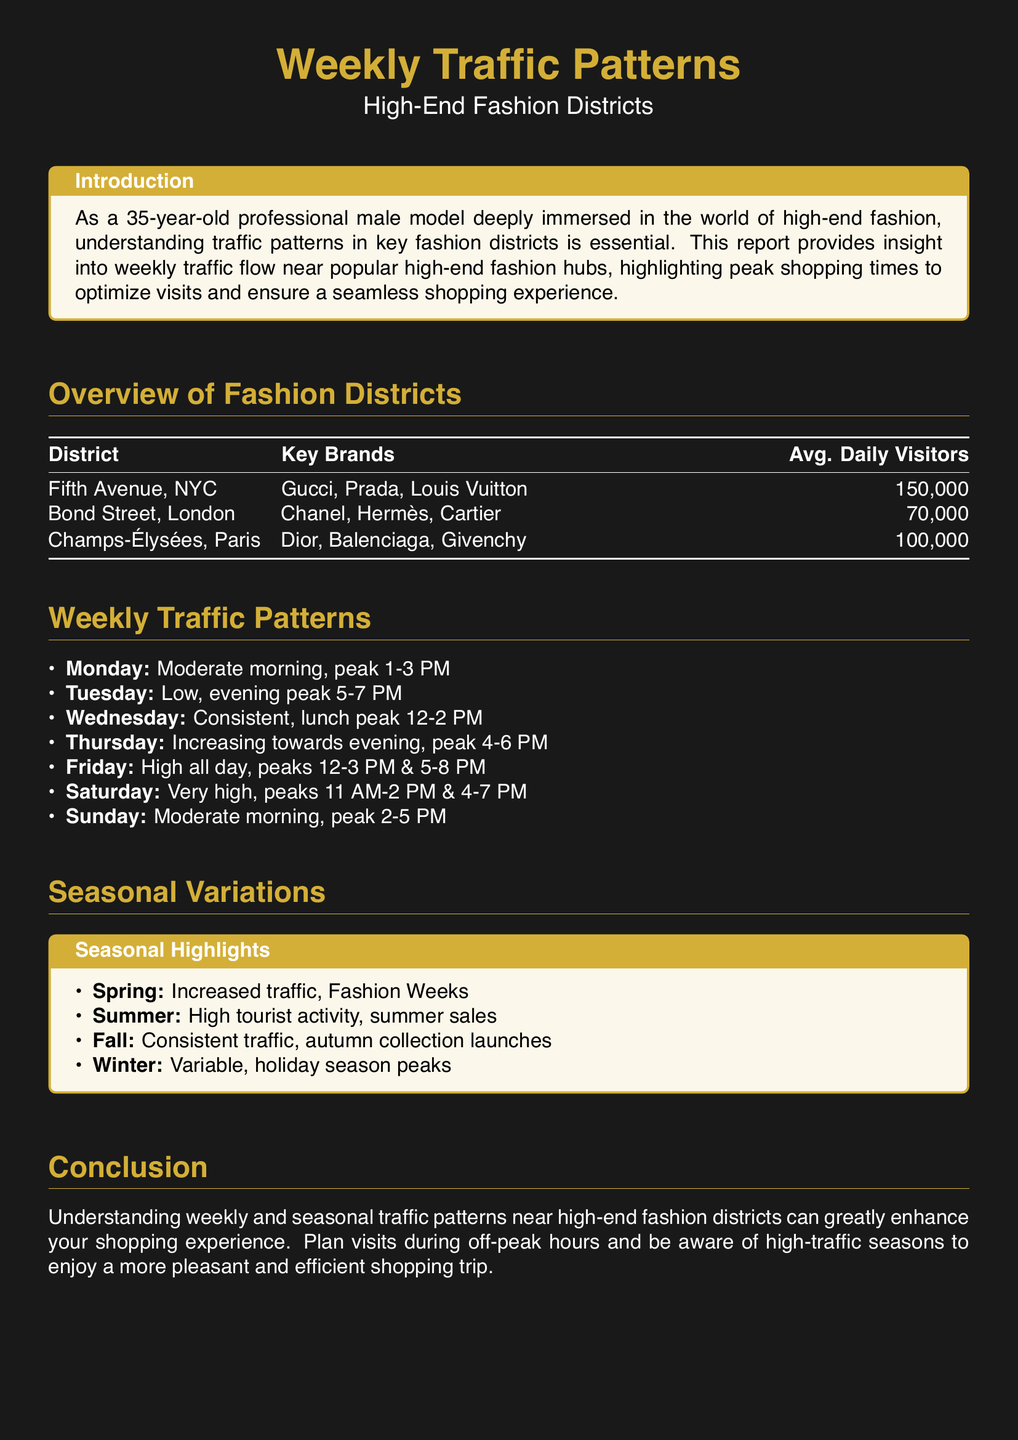What is the average daily visitors for Fifth Avenue? The average daily visitors for Fifth Avenue is explicitly mentioned in the overview table.
Answer: 150,000 What is the peak shopping time on Fridays? The report outlines peak shopping times during the week, specifying timings for each day.
Answer: 12-3 PM & 5-8 PM Which district has the lowest average daily visitors? By comparing the average daily visitors in the overview table, we can find the district with the lowest count.
Answer: Bond Street, London How does traffic vary in spring? This information can be gathered from the seasonal highlights section regarding spring traffic patterns.
Answer: Increased traffic, Fashion Weeks What is the average daily visitor count for Champs-Élysées? The overview table lists the average daily visitors for this district.
Answer: 100,000 What time on Saturdays sees the highest traffic? The weekly traffic patterns specify peak times for Saturdays.
Answer: 11 AM-2 PM & 4-7 PM What is the traffic pattern on Tuesdays? The report provides specific traffic patterns for each day, including Tuesday's details.
Answer: Low, evening peak 5-7 PM What notable event increases traffic in summer? The seasonal highlights section indicates events that affect traffic throughout the year, specifically for summer.
Answer: High tourist activity, summer sales 